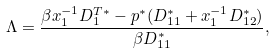<formula> <loc_0><loc_0><loc_500><loc_500>\Lambda = \frac { \beta x _ { 1 } ^ { - 1 } D _ { 1 } ^ { T * } - p ^ { * } ( D _ { 1 1 } ^ { * } + x _ { 1 } ^ { - 1 } D _ { 1 2 } ^ { * } ) } { \beta D _ { 1 1 } ^ { * } } ,</formula> 